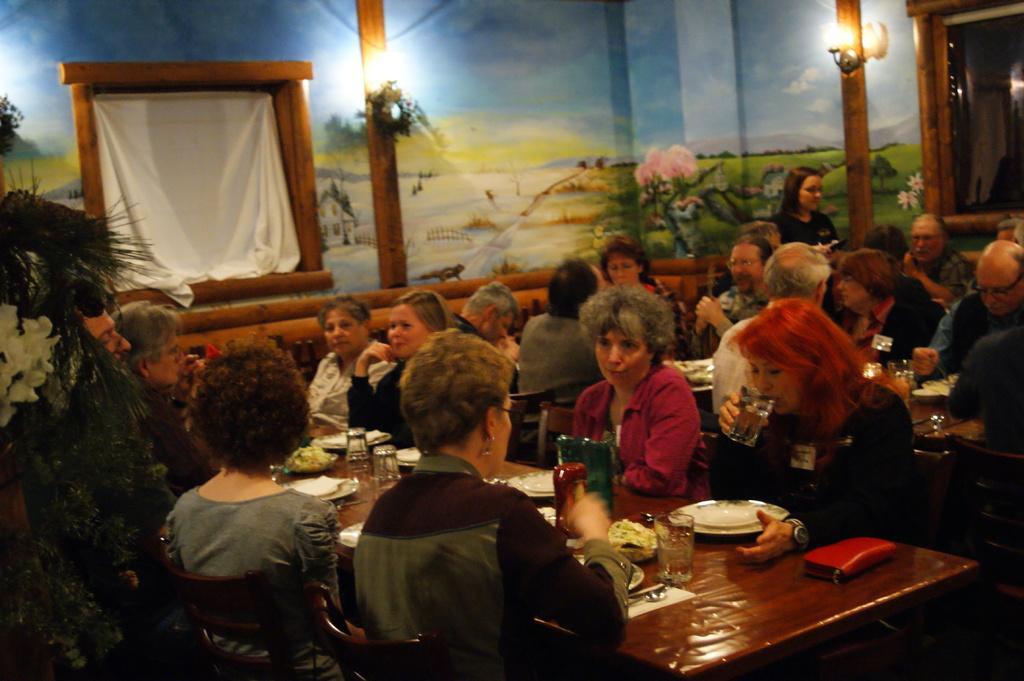How would you summarize this image in a sentence or two? In this picture there are group of people those who are sitting around the dining table and there is a window at the left side of the image and there is a painting on the walls, people those who are sitting on the chairs around the dining table, they are eating there food and there is a plant at the left side of the image. 